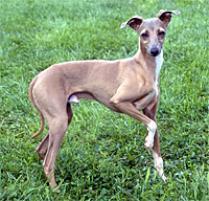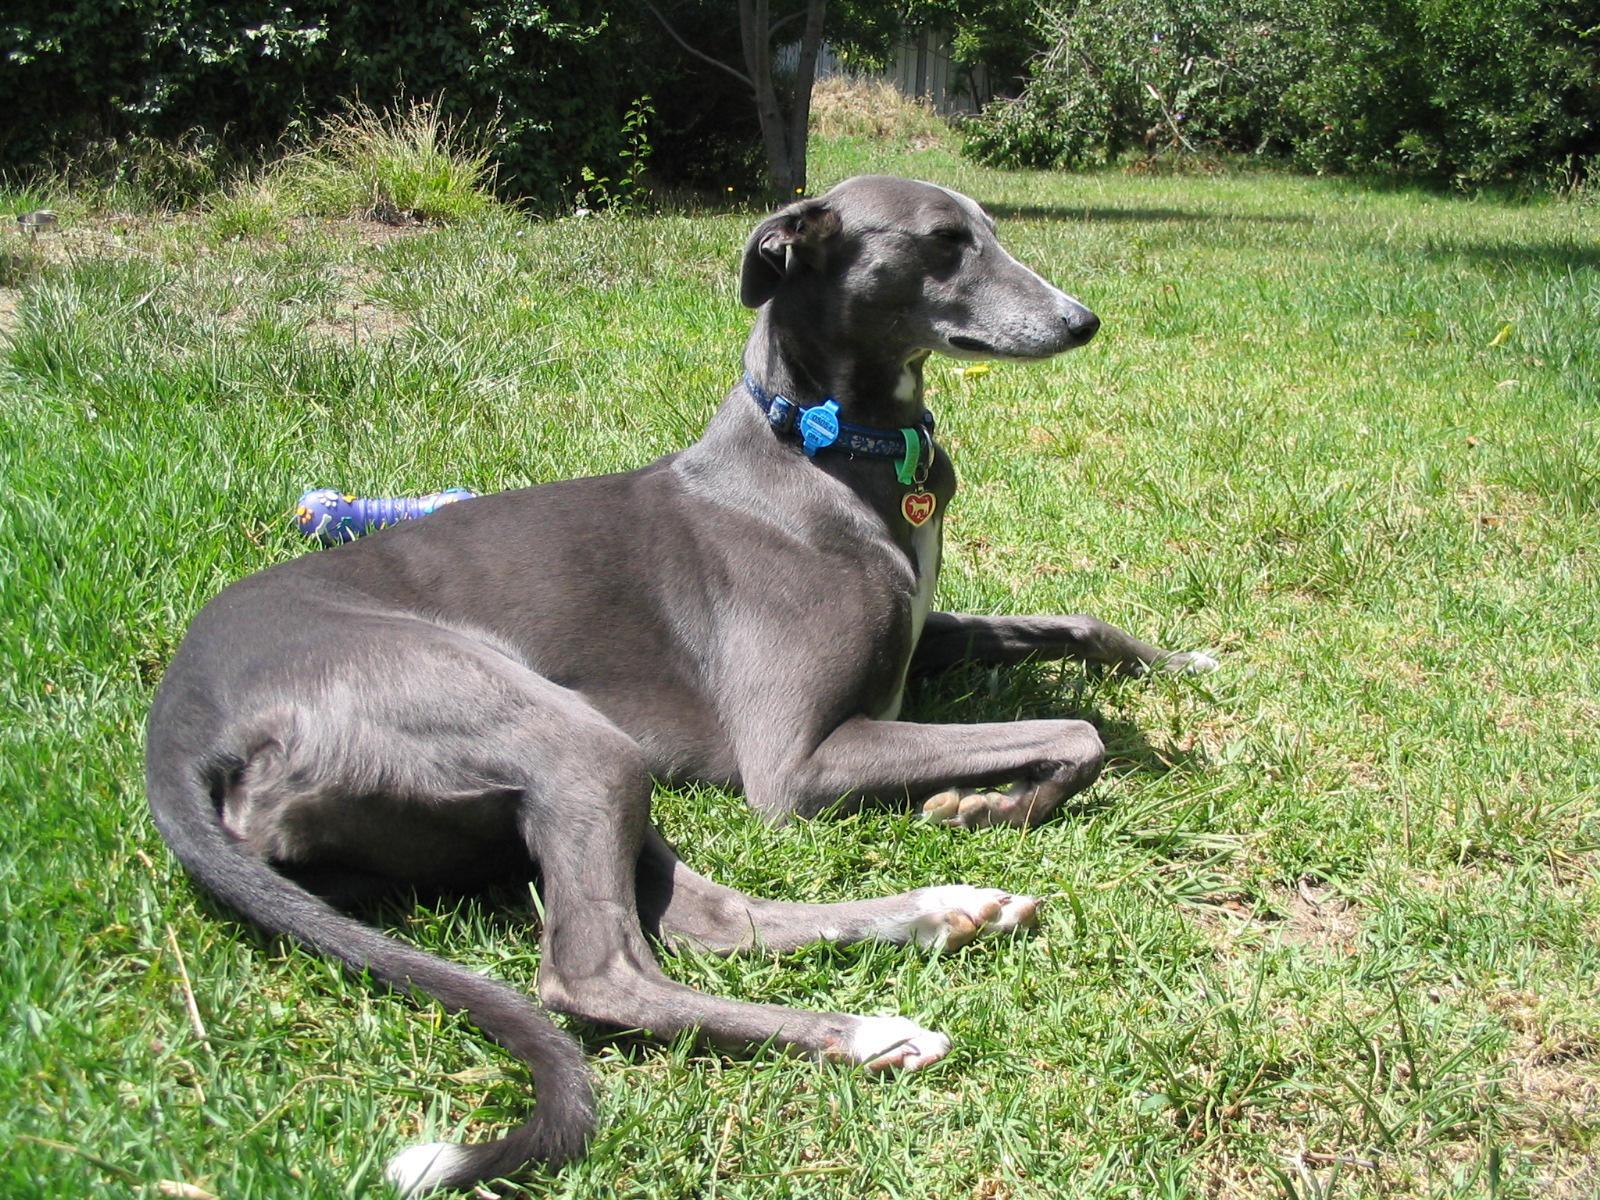The first image is the image on the left, the second image is the image on the right. For the images displayed, is the sentence "The dog in the right image wears a collar." factually correct? Answer yes or no. Yes. 